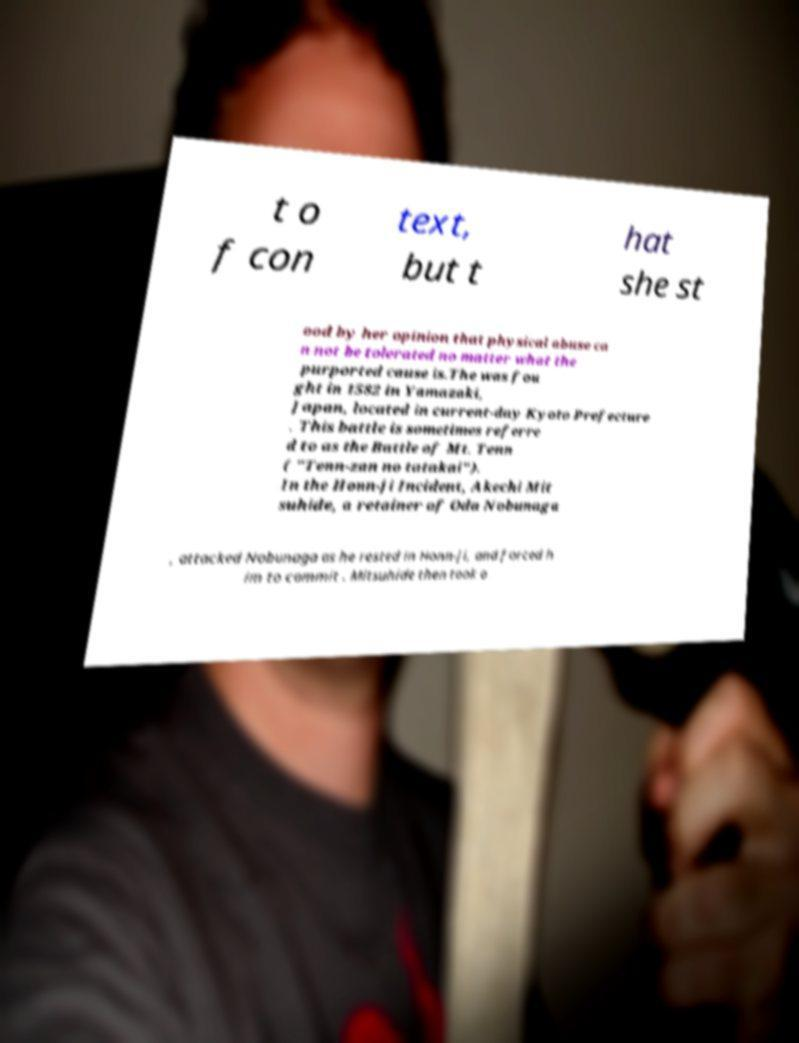Can you read and provide the text displayed in the image?This photo seems to have some interesting text. Can you extract and type it out for me? t o f con text, but t hat she st ood by her opinion that physical abuse ca n not be tolerated no matter what the purported cause is.The was fou ght in 1582 in Yamazaki, Japan, located in current-day Kyoto Prefecture . This battle is sometimes referre d to as the Battle of Mt. Tenn ( "Tenn-zan no tatakai"). In the Honn-ji Incident, Akechi Mit suhide, a retainer of Oda Nobunaga , attacked Nobunaga as he rested in Honn-ji, and forced h im to commit . Mitsuhide then took o 